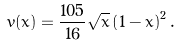<formula> <loc_0><loc_0><loc_500><loc_500>v ( x ) = \frac { 1 0 5 } { 1 6 } \sqrt { x } \left ( 1 - x \right ) ^ { 2 } .</formula> 